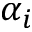Convert formula to latex. <formula><loc_0><loc_0><loc_500><loc_500>\alpha _ { i }</formula> 